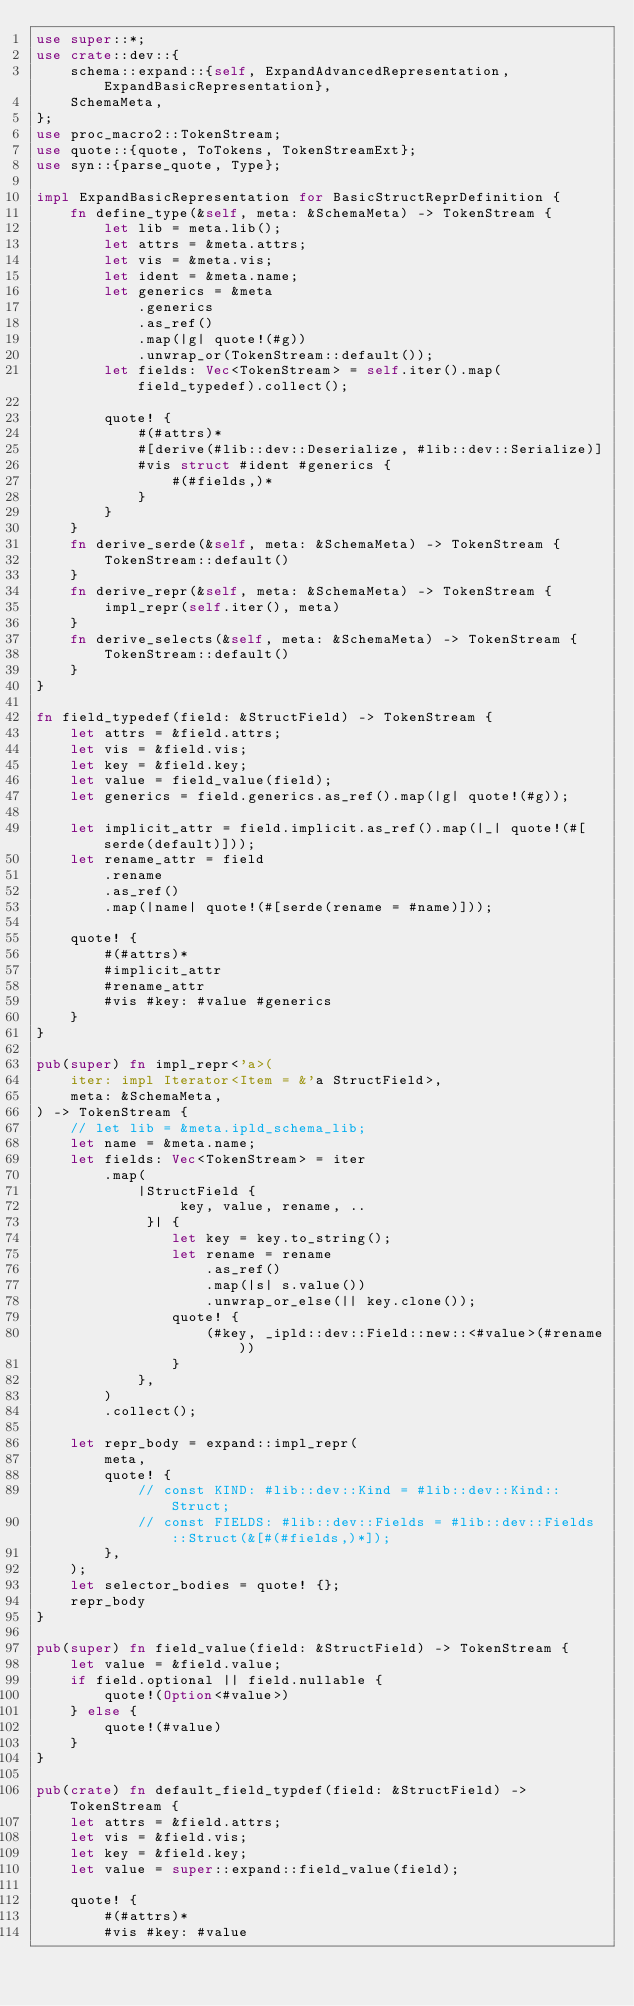<code> <loc_0><loc_0><loc_500><loc_500><_Rust_>use super::*;
use crate::dev::{
    schema::expand::{self, ExpandAdvancedRepresentation, ExpandBasicRepresentation},
    SchemaMeta,
};
use proc_macro2::TokenStream;
use quote::{quote, ToTokens, TokenStreamExt};
use syn::{parse_quote, Type};

impl ExpandBasicRepresentation for BasicStructReprDefinition {
    fn define_type(&self, meta: &SchemaMeta) -> TokenStream {
        let lib = meta.lib();
        let attrs = &meta.attrs;
        let vis = &meta.vis;
        let ident = &meta.name;
        let generics = &meta
            .generics
            .as_ref()
            .map(|g| quote!(#g))
            .unwrap_or(TokenStream::default());
        let fields: Vec<TokenStream> = self.iter().map(field_typedef).collect();

        quote! {
            #(#attrs)*
            #[derive(#lib::dev::Deserialize, #lib::dev::Serialize)]
            #vis struct #ident #generics {
                #(#fields,)*
            }
        }
    }
    fn derive_serde(&self, meta: &SchemaMeta) -> TokenStream {
        TokenStream::default()
    }
    fn derive_repr(&self, meta: &SchemaMeta) -> TokenStream {
        impl_repr(self.iter(), meta)
    }
    fn derive_selects(&self, meta: &SchemaMeta) -> TokenStream {
        TokenStream::default()
    }
}

fn field_typedef(field: &StructField) -> TokenStream {
    let attrs = &field.attrs;
    let vis = &field.vis;
    let key = &field.key;
    let value = field_value(field);
    let generics = field.generics.as_ref().map(|g| quote!(#g));

    let implicit_attr = field.implicit.as_ref().map(|_| quote!(#[serde(default)]));
    let rename_attr = field
        .rename
        .as_ref()
        .map(|name| quote!(#[serde(rename = #name)]));

    quote! {
        #(#attrs)*
        #implicit_attr
        #rename_attr
        #vis #key: #value #generics
    }
}

pub(super) fn impl_repr<'a>(
    iter: impl Iterator<Item = &'a StructField>,
    meta: &SchemaMeta,
) -> TokenStream {
    // let lib = &meta.ipld_schema_lib;
    let name = &meta.name;
    let fields: Vec<TokenStream> = iter
        .map(
            |StructField {
                 key, value, rename, ..
             }| {
                let key = key.to_string();
                let rename = rename
                    .as_ref()
                    .map(|s| s.value())
                    .unwrap_or_else(|| key.clone());
                quote! {
                    (#key, _ipld::dev::Field::new::<#value>(#rename))
                }
            },
        )
        .collect();

    let repr_body = expand::impl_repr(
        meta,
        quote! {
            // const KIND: #lib::dev::Kind = #lib::dev::Kind::Struct;
            // const FIELDS: #lib::dev::Fields = #lib::dev::Fields::Struct(&[#(#fields,)*]);
        },
    );
    let selector_bodies = quote! {};
    repr_body
}

pub(super) fn field_value(field: &StructField) -> TokenStream {
    let value = &field.value;
    if field.optional || field.nullable {
        quote!(Option<#value>)
    } else {
        quote!(#value)
    }
}

pub(crate) fn default_field_typdef(field: &StructField) -> TokenStream {
    let attrs = &field.attrs;
    let vis = &field.vis;
    let key = &field.key;
    let value = super::expand::field_value(field);

    quote! {
        #(#attrs)*
        #vis #key: #value</code> 